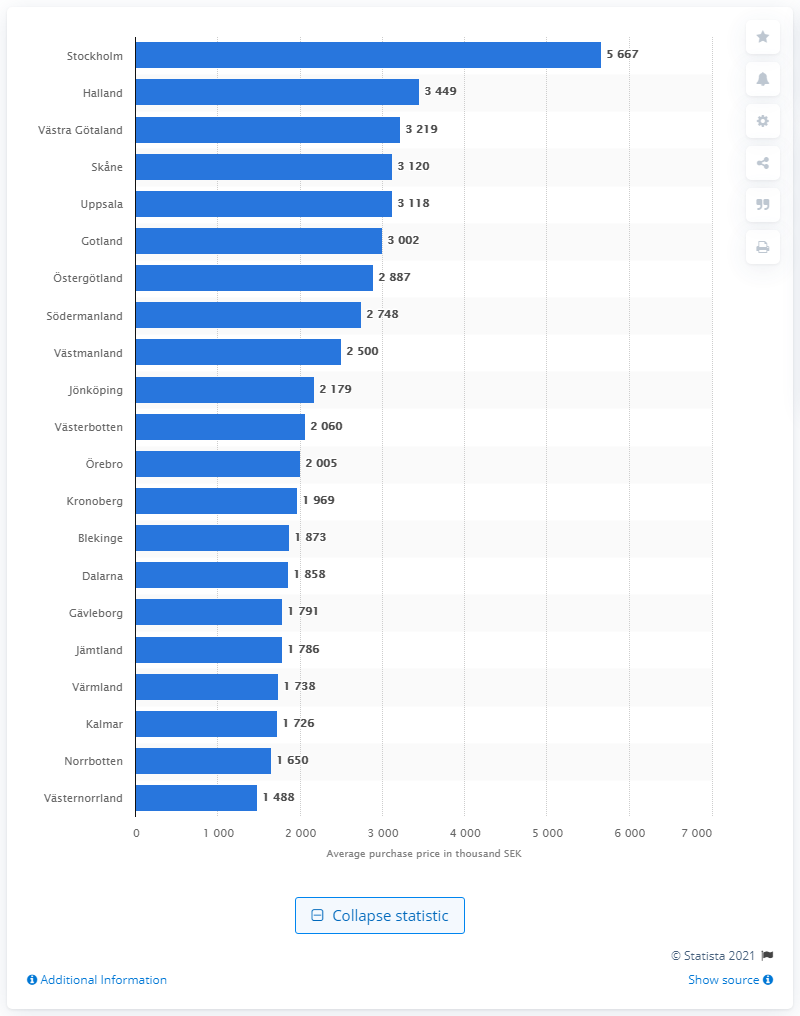Where was the highest average purchase price for one- and two-residential property in Sweden in 2019?
 Stockholm 